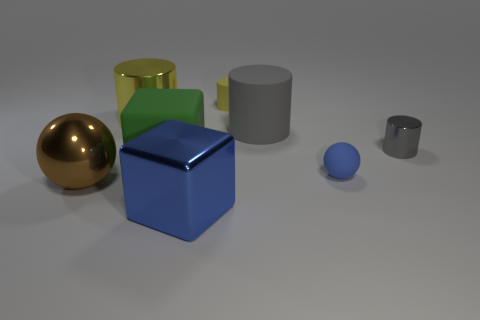Subtract all big matte cylinders. How many cylinders are left? 3 Subtract all yellow cylinders. How many cylinders are left? 2 Add 1 tiny yellow matte balls. How many objects exist? 9 Add 8 large blue cubes. How many large blue cubes are left? 9 Add 7 brown spheres. How many brown spheres exist? 8 Subtract 0 purple cylinders. How many objects are left? 8 Subtract all cubes. How many objects are left? 6 Subtract 1 spheres. How many spheres are left? 1 Subtract all green balls. Subtract all blue cylinders. How many balls are left? 2 Subtract all cyan cylinders. How many green blocks are left? 1 